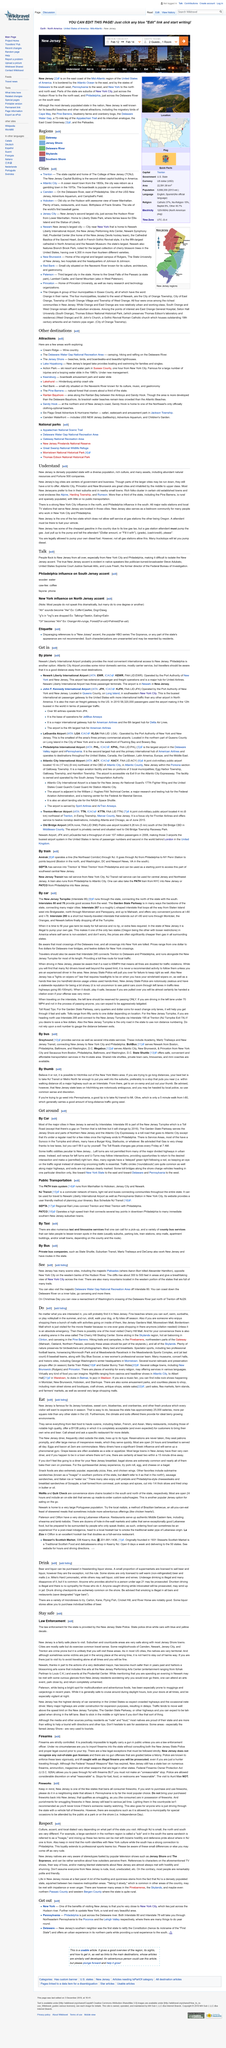Outline some significant characteristics in this image. New Jersey is home to several great cities that are known for their unique charm and cultural attractions. These cities include Atlantic City, Princeton, and New Brunswick, which are renowned for their vibrant atmosphere, diverse cuisine, and rich history. Each of these cities offers a unique experience for visitors, with Atlantic City's boardwalk and casinos, Princeton's prestigious universities, and New Brunswick's thriving arts scene. Two TV shows, Jersey Shore and The Sopranos, perpetuate stereotypes about people from New Jersey and are examples of media that reinforce harmful generalizations about residents of the state. You will find concentrations of wealthy individuals in established towns and rural enclaves such as Alpine, Harding Township, and Rumson. New Jersey serves as a bedroom community for many individuals who commute to work in New York City and Philadelphia. Many people hold the stereotype that those who hail from the state of New Jersey are rude, loud, and uneducated. 